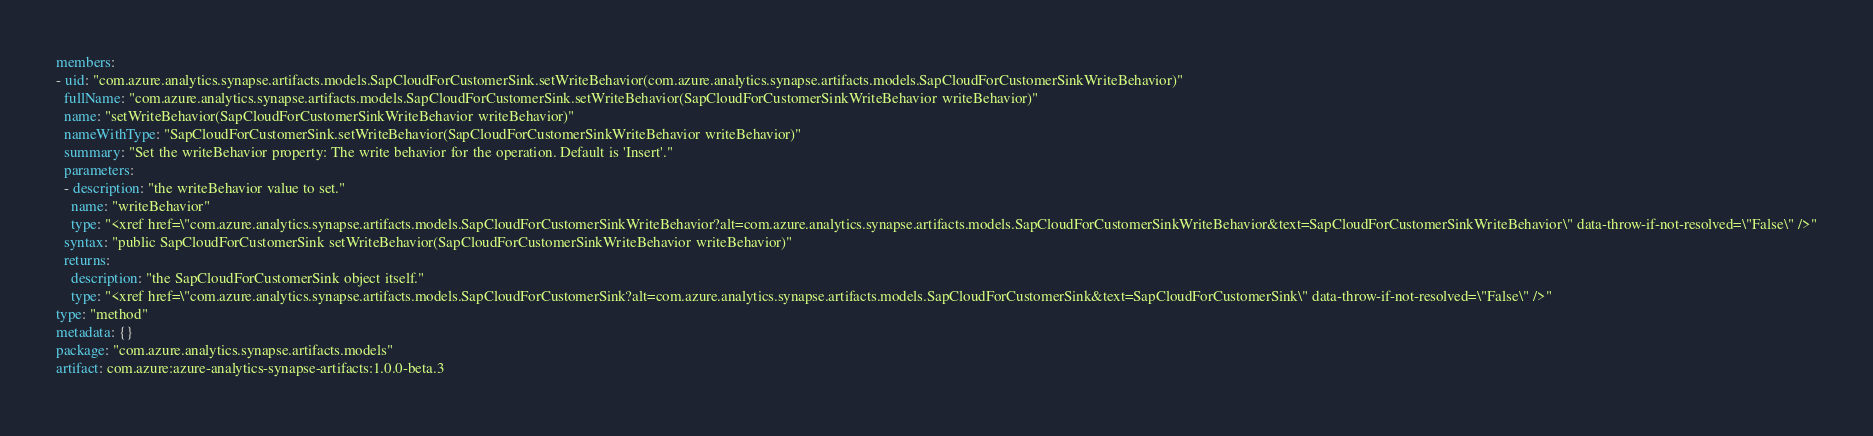Convert code to text. <code><loc_0><loc_0><loc_500><loc_500><_YAML_>members:
- uid: "com.azure.analytics.synapse.artifacts.models.SapCloudForCustomerSink.setWriteBehavior(com.azure.analytics.synapse.artifacts.models.SapCloudForCustomerSinkWriteBehavior)"
  fullName: "com.azure.analytics.synapse.artifacts.models.SapCloudForCustomerSink.setWriteBehavior(SapCloudForCustomerSinkWriteBehavior writeBehavior)"
  name: "setWriteBehavior(SapCloudForCustomerSinkWriteBehavior writeBehavior)"
  nameWithType: "SapCloudForCustomerSink.setWriteBehavior(SapCloudForCustomerSinkWriteBehavior writeBehavior)"
  summary: "Set the writeBehavior property: The write behavior for the operation. Default is 'Insert'."
  parameters:
  - description: "the writeBehavior value to set."
    name: "writeBehavior"
    type: "<xref href=\"com.azure.analytics.synapse.artifacts.models.SapCloudForCustomerSinkWriteBehavior?alt=com.azure.analytics.synapse.artifacts.models.SapCloudForCustomerSinkWriteBehavior&text=SapCloudForCustomerSinkWriteBehavior\" data-throw-if-not-resolved=\"False\" />"
  syntax: "public SapCloudForCustomerSink setWriteBehavior(SapCloudForCustomerSinkWriteBehavior writeBehavior)"
  returns:
    description: "the SapCloudForCustomerSink object itself."
    type: "<xref href=\"com.azure.analytics.synapse.artifacts.models.SapCloudForCustomerSink?alt=com.azure.analytics.synapse.artifacts.models.SapCloudForCustomerSink&text=SapCloudForCustomerSink\" data-throw-if-not-resolved=\"False\" />"
type: "method"
metadata: {}
package: "com.azure.analytics.synapse.artifacts.models"
artifact: com.azure:azure-analytics-synapse-artifacts:1.0.0-beta.3
</code> 